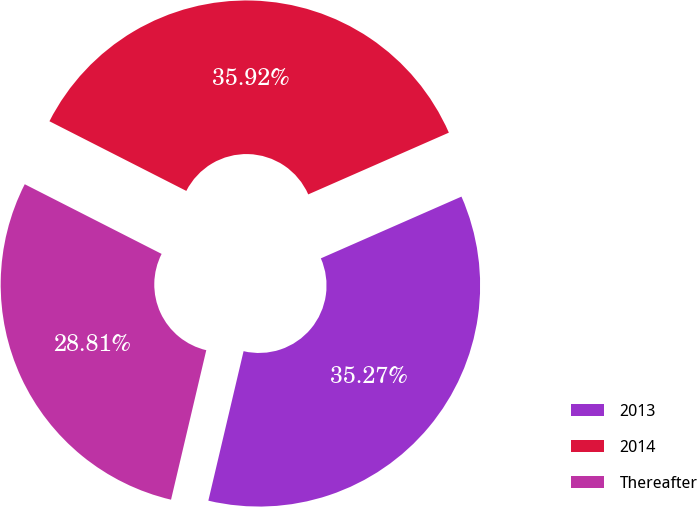Convert chart. <chart><loc_0><loc_0><loc_500><loc_500><pie_chart><fcel>2013<fcel>2014<fcel>Thereafter<nl><fcel>35.27%<fcel>35.92%<fcel>28.81%<nl></chart> 